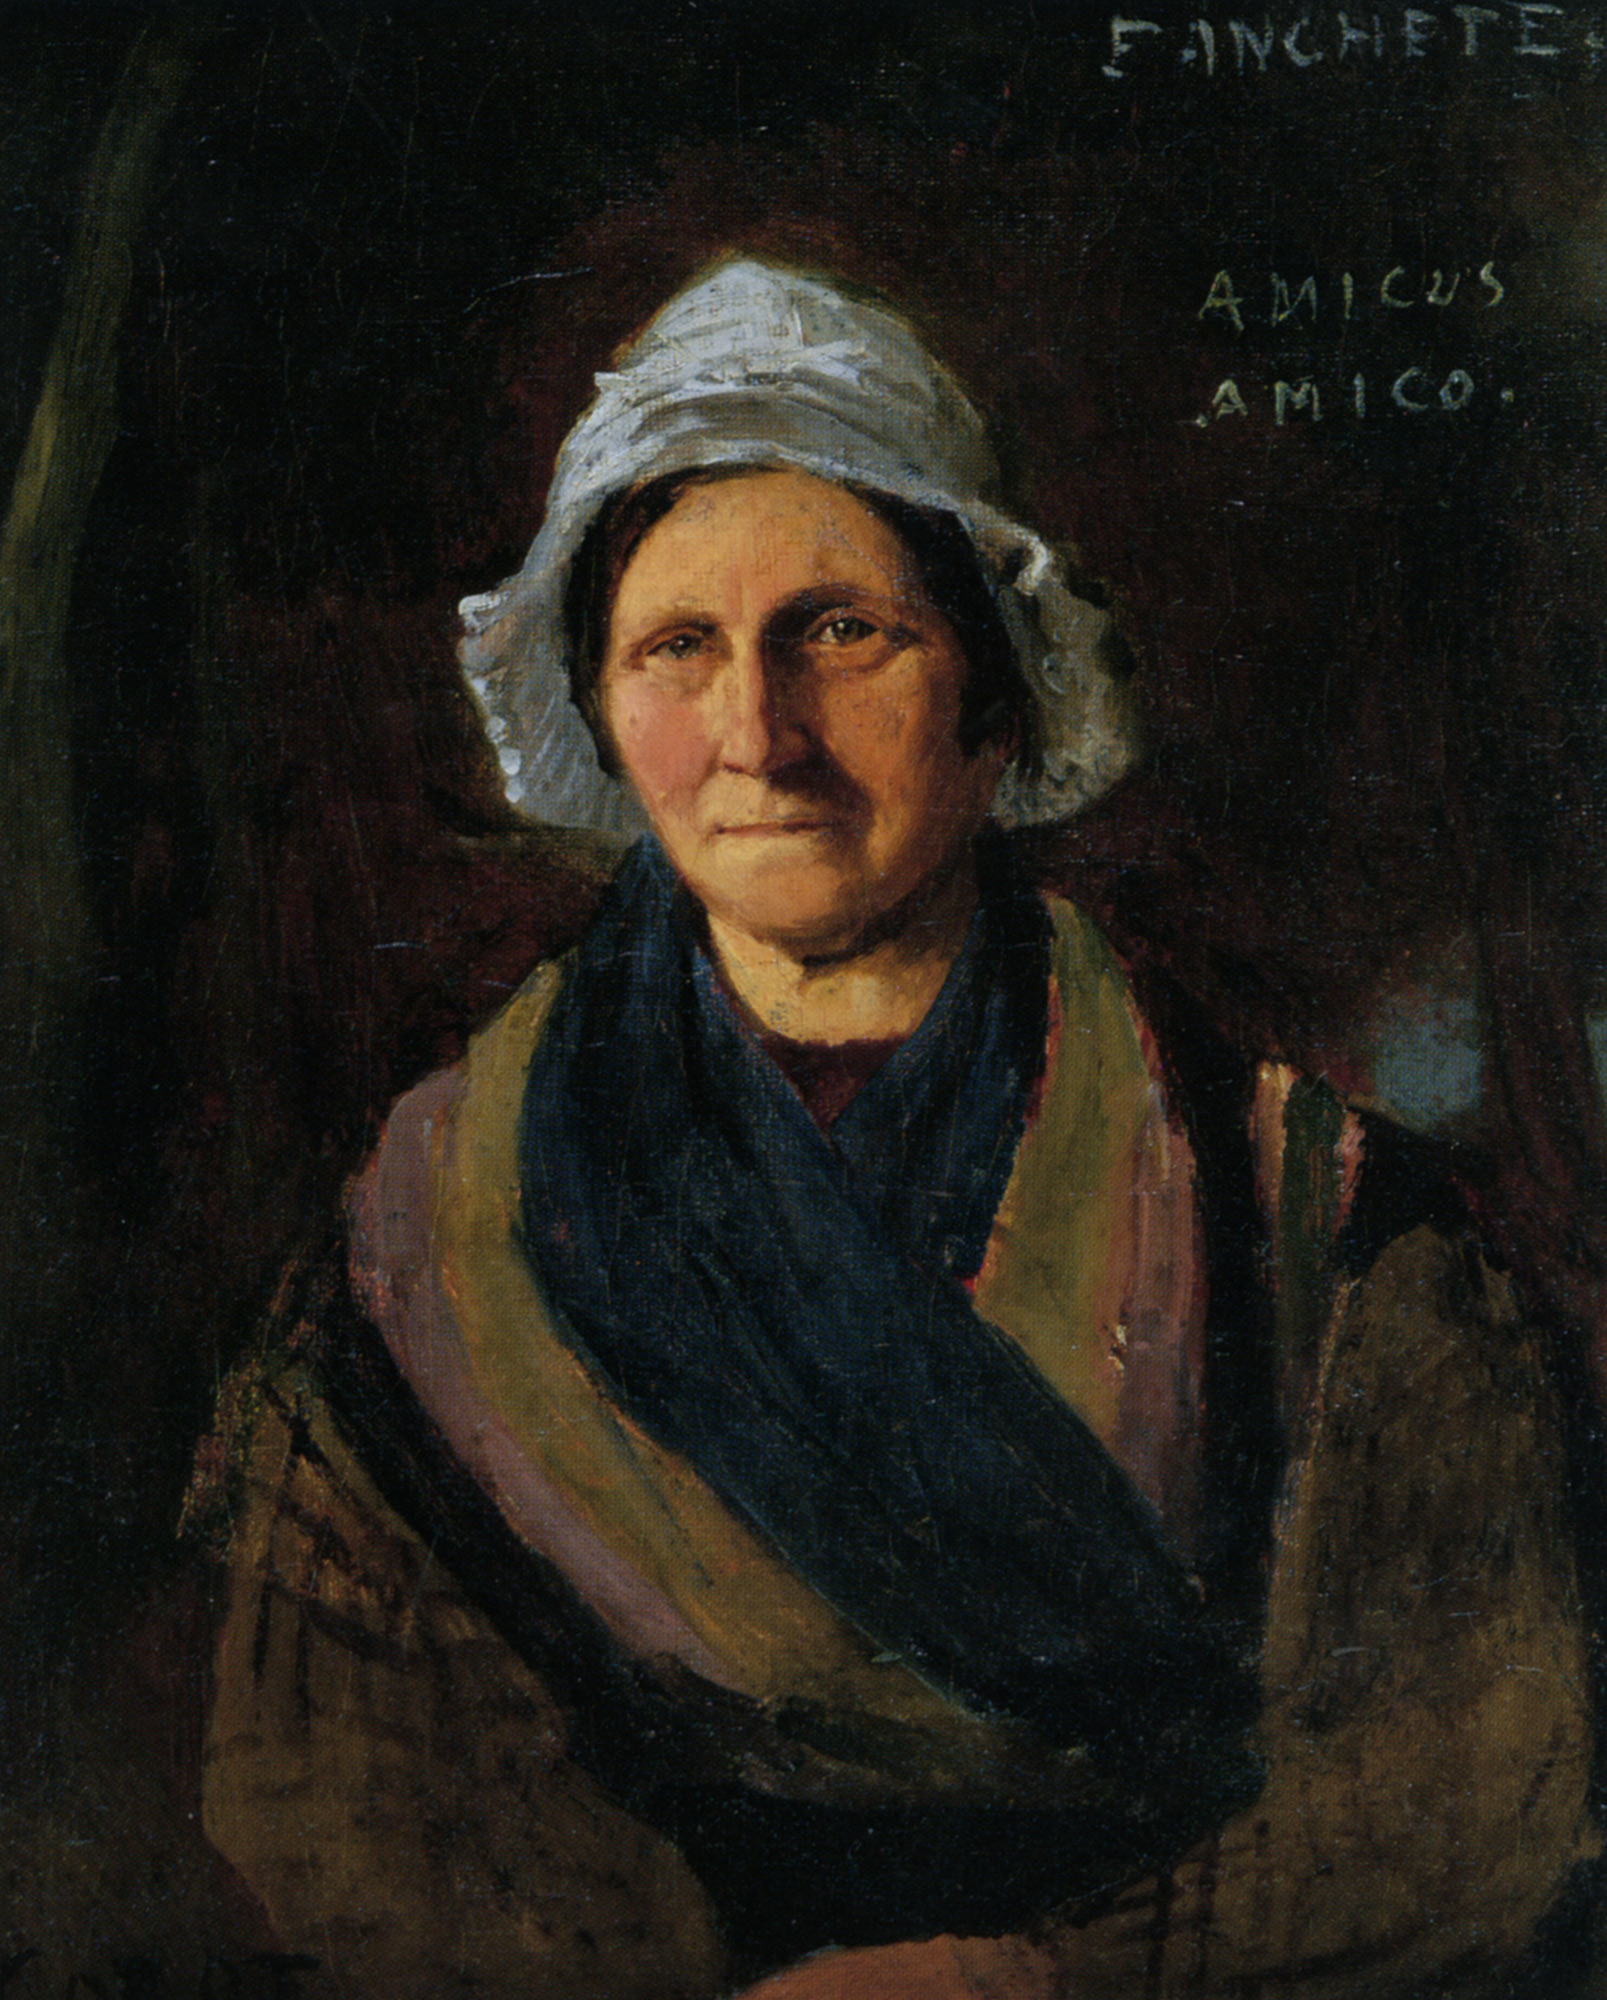Can you elaborate on the elements of the picture provided? The image features a striking oil painting of a mature woman dressed in traditional attire, capped with a white bonnet and draped in a vivid blue shawl. The background of the painting is intentionally dim, highlighting the subject's features and attire through skillful use of contrast. This technique draws the viewer’s attention squarely to the woman, emphasizing her dignified expression and the texture of her clothing. The signature 'FINCHETE AMICUS AMICO', scrawled in the upper right, suggests a personal connection or dedication by the artist, adding an intriguing layer of narrative to the piece. Such elements not only demonstrate the artist's mastery of portraiture but also hint at the deeper stories and emotions captured within the brushstrokes. 